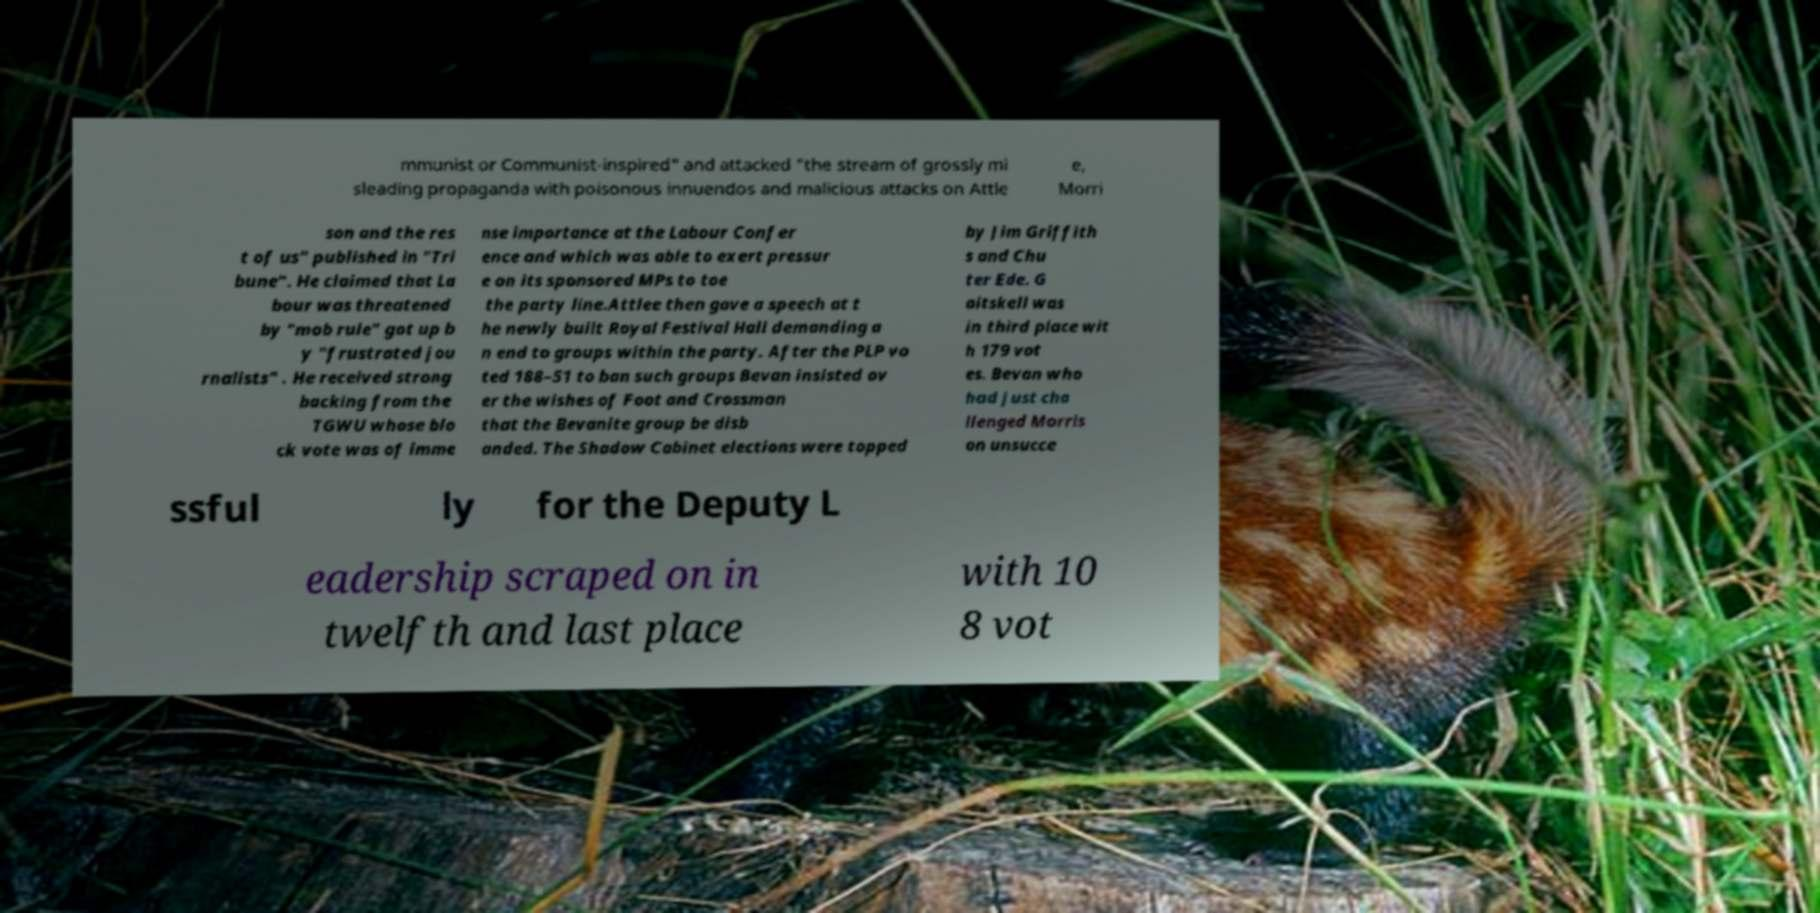I need the written content from this picture converted into text. Can you do that? mmunist or Communist-inspired" and attacked "the stream of grossly mi sleading propaganda with poisonous innuendos and malicious attacks on Attle e, Morri son and the res t of us" published in "Tri bune". He claimed that La bour was threatened by "mob rule" got up b y "frustrated jou rnalists" . He received strong backing from the TGWU whose blo ck vote was of imme nse importance at the Labour Confer ence and which was able to exert pressur e on its sponsored MPs to toe the party line.Attlee then gave a speech at t he newly built Royal Festival Hall demanding a n end to groups within the party. After the PLP vo ted 188–51 to ban such groups Bevan insisted ov er the wishes of Foot and Crossman that the Bevanite group be disb anded. The Shadow Cabinet elections were topped by Jim Griffith s and Chu ter Ede. G aitskell was in third place wit h 179 vot es. Bevan who had just cha llenged Morris on unsucce ssful ly for the Deputy L eadership scraped on in twelfth and last place with 10 8 vot 